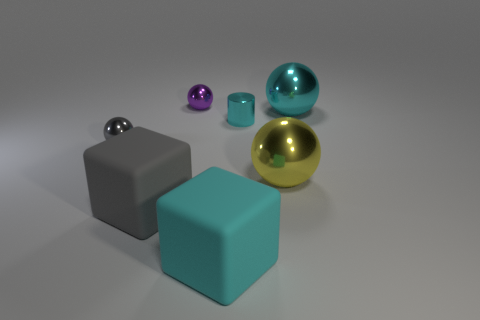Subtract 1 balls. How many balls are left? 3 Subtract all brown blocks. Subtract all purple cylinders. How many blocks are left? 2 Add 2 big yellow rubber balls. How many objects exist? 9 Subtract all cylinders. How many objects are left? 6 Subtract 0 brown balls. How many objects are left? 7 Subtract all large cyan rubber cylinders. Subtract all large gray matte objects. How many objects are left? 6 Add 3 gray balls. How many gray balls are left? 4 Add 7 gray metallic balls. How many gray metallic balls exist? 8 